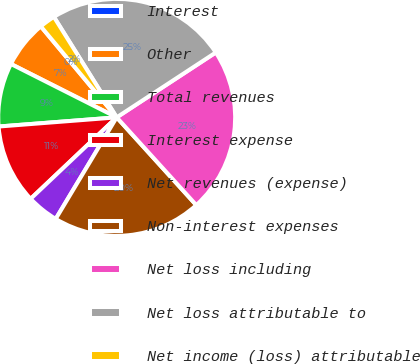Convert chart. <chart><loc_0><loc_0><loc_500><loc_500><pie_chart><fcel>Interest<fcel>Other<fcel>Total revenues<fcel>Interest expense<fcel>Net revenues (expense)<fcel>Non-interest expenses<fcel>Net loss including<fcel>Net loss attributable to<fcel>Net income (loss) attributable<nl><fcel>0.0%<fcel>6.5%<fcel>8.67%<fcel>10.83%<fcel>4.33%<fcel>20.33%<fcel>22.5%<fcel>24.66%<fcel>2.17%<nl></chart> 